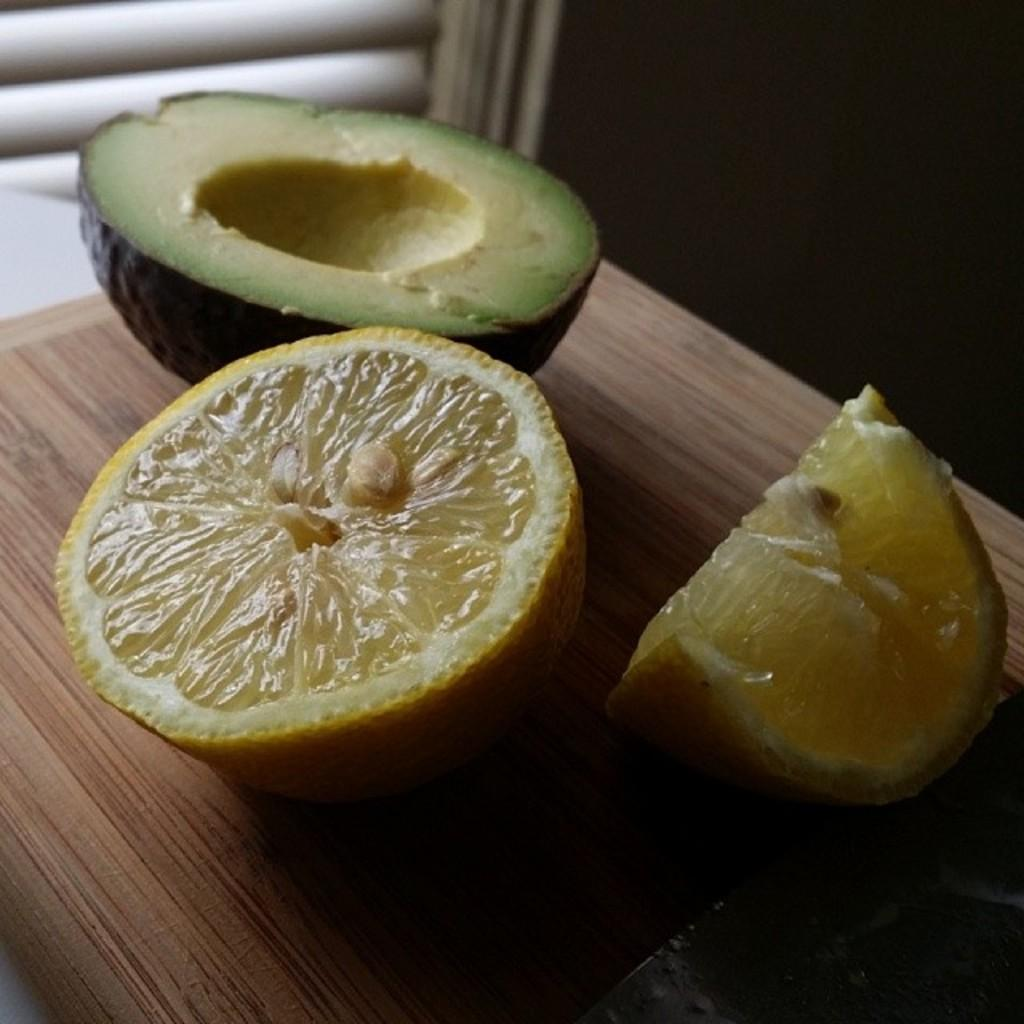What type of food can be seen in the image? There are pieces of orange and avocado in the image. What is the surface on which the food is placed? The wooden surface is visible in the image. What type of jelly can be seen in the image? There is no jelly present in the image; it features pieces of orange and avocado. What type of bun is visible in the image? There is no bun present in the image. 